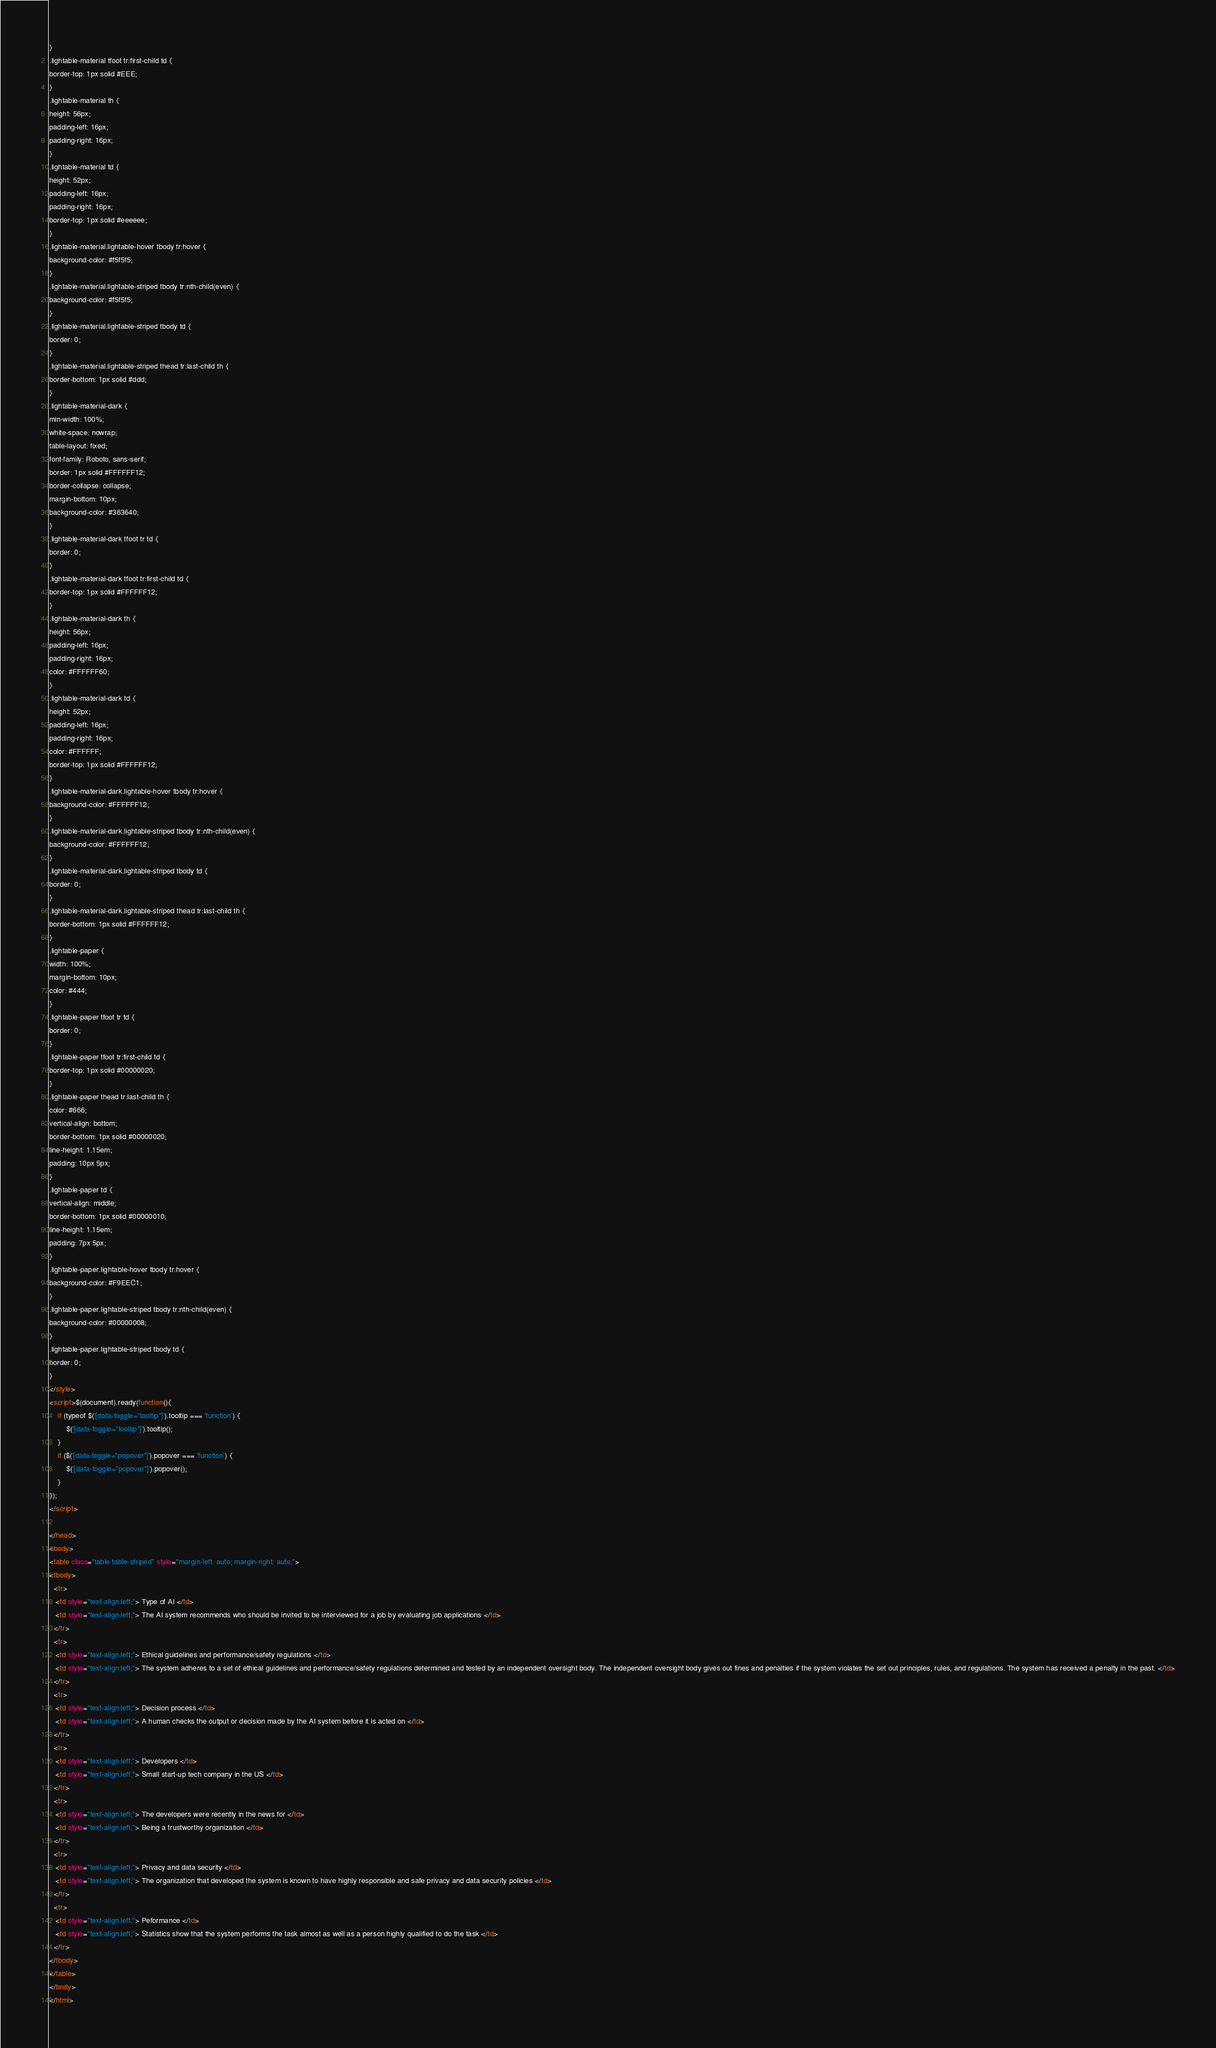Convert code to text. <code><loc_0><loc_0><loc_500><loc_500><_HTML_>}
.lightable-material tfoot tr:first-child td {
border-top: 1px solid #EEE;
}
.lightable-material th {
height: 56px;
padding-left: 16px;
padding-right: 16px;
}
.lightable-material td {
height: 52px;
padding-left: 16px;
padding-right: 16px;
border-top: 1px solid #eeeeee;
}
.lightable-material.lightable-hover tbody tr:hover {
background-color: #f5f5f5;
}
.lightable-material.lightable-striped tbody tr:nth-child(even) {
background-color: #f5f5f5;
}
.lightable-material.lightable-striped tbody td {
border: 0;
}
.lightable-material.lightable-striped thead tr:last-child th {
border-bottom: 1px solid #ddd;
}
.lightable-material-dark {
min-width: 100%;
white-space: nowrap;
table-layout: fixed;
font-family: Roboto, sans-serif;
border: 1px solid #FFFFFF12;
border-collapse: collapse;
margin-bottom: 10px;
background-color: #363640;
}
.lightable-material-dark tfoot tr td {
border: 0;
}
.lightable-material-dark tfoot tr:first-child td {
border-top: 1px solid #FFFFFF12;
}
.lightable-material-dark th {
height: 56px;
padding-left: 16px;
padding-right: 16px;
color: #FFFFFF60;
}
.lightable-material-dark td {
height: 52px;
padding-left: 16px;
padding-right: 16px;
color: #FFFFFF;
border-top: 1px solid #FFFFFF12;
}
.lightable-material-dark.lightable-hover tbody tr:hover {
background-color: #FFFFFF12;
}
.lightable-material-dark.lightable-striped tbody tr:nth-child(even) {
background-color: #FFFFFF12;
}
.lightable-material-dark.lightable-striped tbody td {
border: 0;
}
.lightable-material-dark.lightable-striped thead tr:last-child th {
border-bottom: 1px solid #FFFFFF12;
}
.lightable-paper {
width: 100%;
margin-bottom: 10px;
color: #444;
}
.lightable-paper tfoot tr td {
border: 0;
}
.lightable-paper tfoot tr:first-child td {
border-top: 1px solid #00000020;
}
.lightable-paper thead tr:last-child th {
color: #666;
vertical-align: bottom;
border-bottom: 1px solid #00000020;
line-height: 1.15em;
padding: 10px 5px;
}
.lightable-paper td {
vertical-align: middle;
border-bottom: 1px solid #00000010;
line-height: 1.15em;
padding: 7px 5px;
}
.lightable-paper.lightable-hover tbody tr:hover {
background-color: #F9EEC1;
}
.lightable-paper.lightable-striped tbody tr:nth-child(even) {
background-color: #00000008;
}
.lightable-paper.lightable-striped tbody td {
border: 0;
}
</style>
<script>$(document).ready(function(){
    if (typeof $('[data-toggle="tooltip"]').tooltip === 'function') {
        $('[data-toggle="tooltip"]').tooltip();
    }
    if ($('[data-toggle="popover"]').popover === 'function') {
        $('[data-toggle="popover"]').popover();
    }
});
</script>

</head>
<body>
<table class="table table-striped" style="margin-left: auto; margin-right: auto;">
<tbody>
  <tr>
   <td style="text-align:left;"> Type of AI </td>
   <td style="text-align:left;"> The AI system recommends who should be invited to be interviewed for a job by evaluating job applications </td>
  </tr>
  <tr>
   <td style="text-align:left;"> Ethical guidelines and performance/safety regulations </td>
   <td style="text-align:left;"> The system adheres to a set of ethical guidelines and performance/safety regulations determined and tested by an independent oversight body. The independent oversight body gives out fines and penalties if the system violates the set out principles, rules, and regulations. The system has received a penalty in the past. </td>
  </tr>
  <tr>
   <td style="text-align:left;"> Decision process </td>
   <td style="text-align:left;"> A human checks the output or decision made by the AI system before it is acted on </td>
  </tr>
  <tr>
   <td style="text-align:left;"> Developers </td>
   <td style="text-align:left;"> Small start-up tech company in the US </td>
  </tr>
  <tr>
   <td style="text-align:left;"> The developers were recently in the news for </td>
   <td style="text-align:left;"> Being a trustworthy organization </td>
  </tr>
  <tr>
   <td style="text-align:left;"> Privacy and data security </td>
   <td style="text-align:left;"> The organization that developed the system is known to have highly responsible and safe privacy and data security policies </td>
  </tr>
  <tr>
   <td style="text-align:left;"> Peformance </td>
   <td style="text-align:left;"> Statistics show that the system performs the task almost as well as a person highly qualified to do the task </td>
  </tr>
</tbody>
</table>
</body>
</html>
</code> 